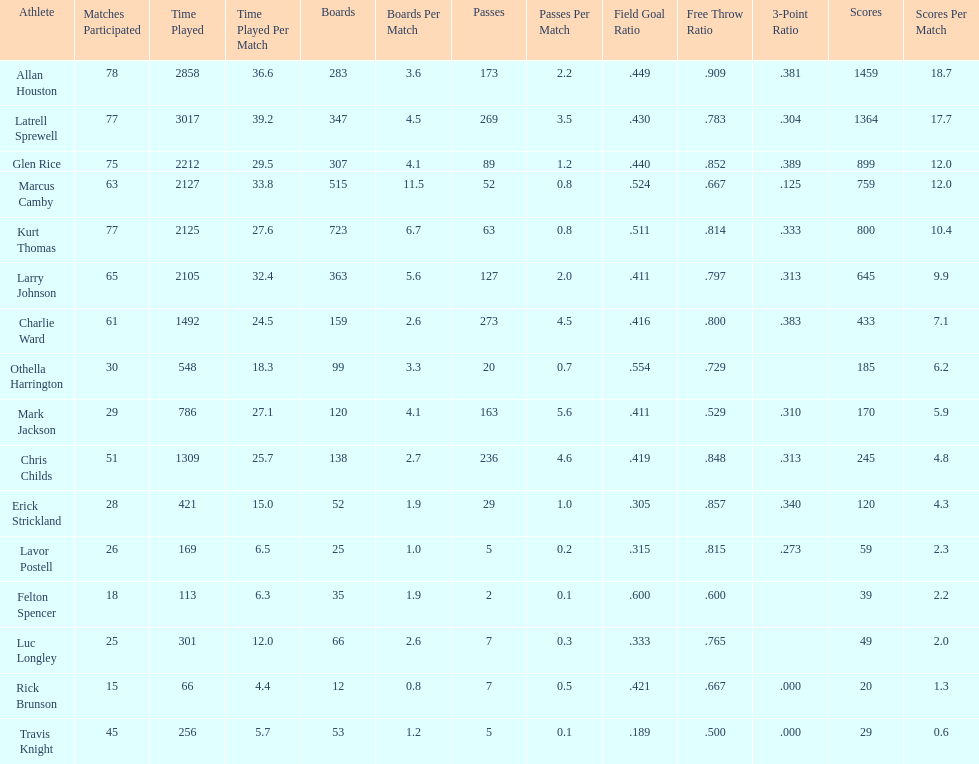Give the number of players covered by the table. 16. 